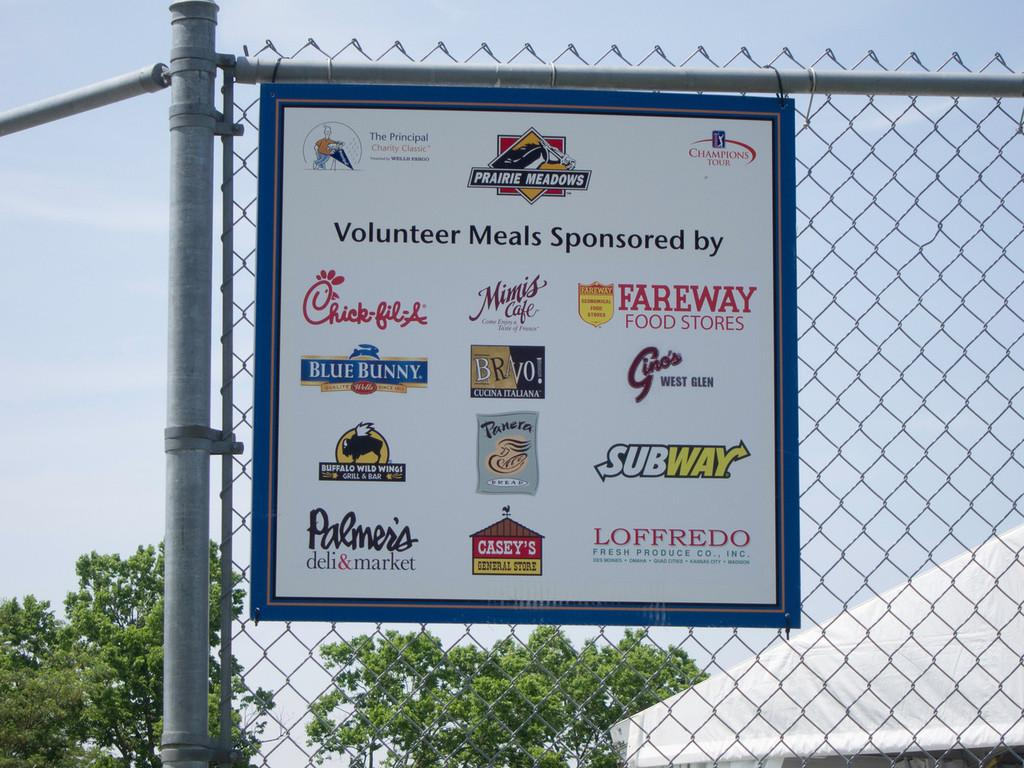<image>
Offer a succinct explanation of the picture presented. a sign that talks about how the volunteer meals are sponsered 